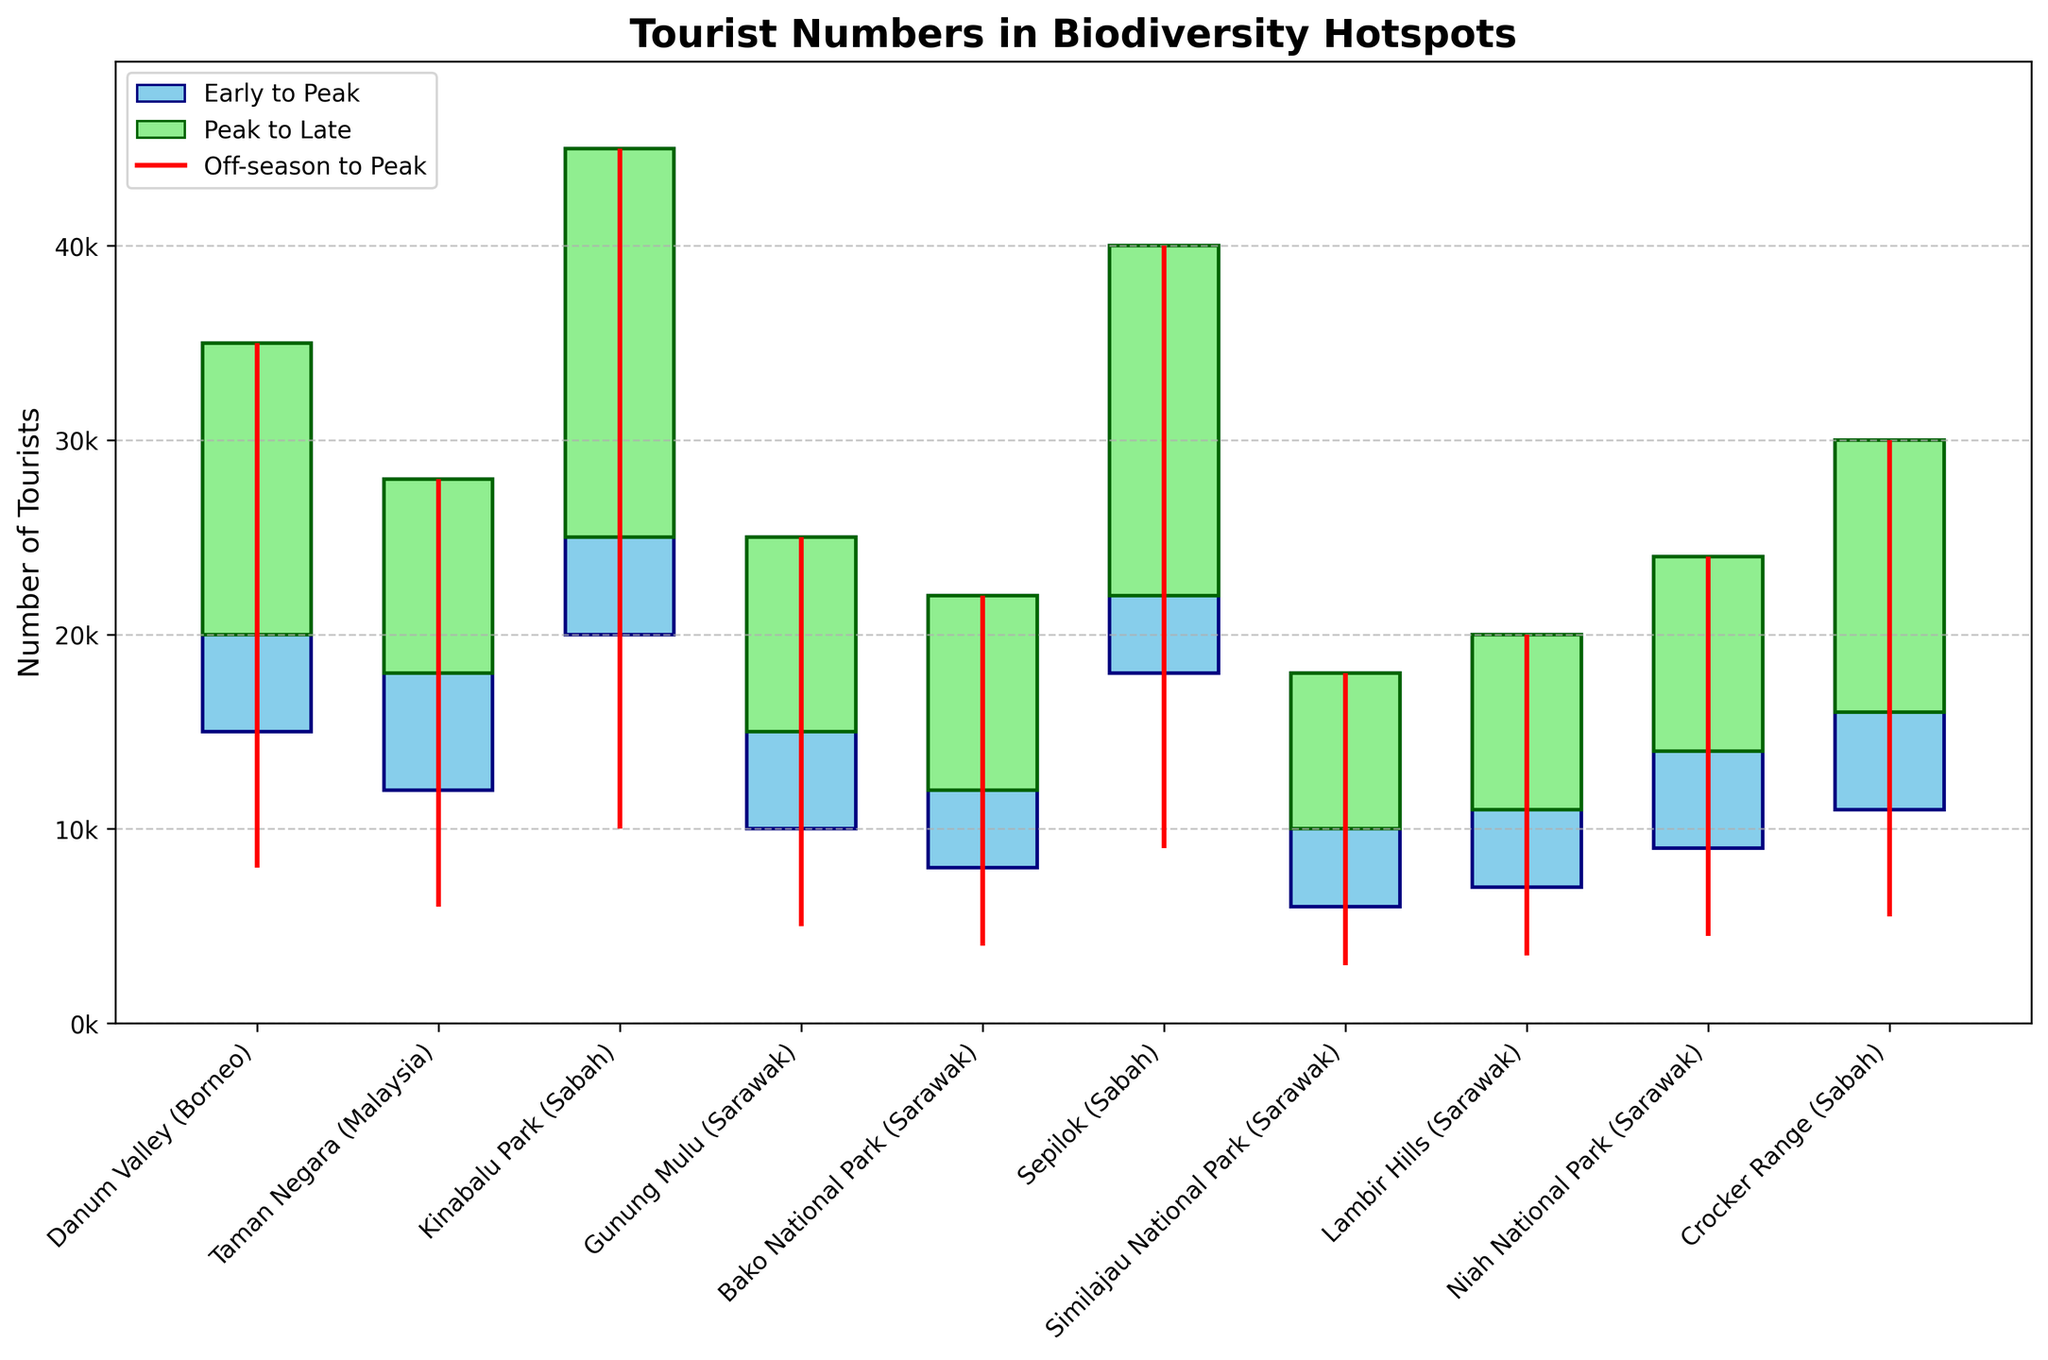What is the title of the chart? The chart title is usually at the top of the figure. In this chart, it is clear from the larger, bold font text at the top of the chart.
Answer: Tourist Numbers in Biodiversity Hotspots Which biodiversity hotspot shows the highest number of tourists in the peak season? Refer to the 'Peak' value bars. The highest peak bar corresponds to Kinabalu Park (Sabah) reaching up to 45,000 tourists.
Answer: Kinabalu Park (Sabah) What is the range of tourist numbers for Bako National Park (Sarawak) across different seasons? The range is the difference between the highest (Peak Season) and the lowest (Off-season) tourist numbers. For Bako National Park, the values are Peak: 22,000 and Off: 4,000. Therefore, the range is 22,000 - 4,000 = 18,000.
Answer: 18,000 Which season has the lowest tourist inflow for Gunung Mulu (Sarawak), and what is the number? The lowest tourist inflow is represented by the smallest value in the 'Off' column. For Gunung Mulu, it is 5,000 tourists in the off-season.
Answer: Off-season, 5,000 Between Danum Valley (Borneo) and Taman Negara (Malaysia), which one has a higher tourist number during the early season? Compare the 'Early' season numbers of both locations. Danum Valley has 15,000 while Taman Negara has 12,000. Thus, Danum Valley has a higher number.
Answer: Danum Valley (Borneo) How much does the number of tourists drop from peak season to off-season in Sepilok (Sabah)? Calculate the difference between the peak season and off-season numbers for Sepilok. The peak is 40,000 and off-season is 9,000. The drop is 40,000 - 9,000 = 31,000.
Answer: 31,000 What is the average peak season tourist number for all the hotspots? Find the peak season numbers for all locations, sum them up, and divide by the number of locations. Sum = 35,000+28,000+45,000+25,000+22,000+40,000+18,000+20,000+24,000+30,000 = 287,000. There are 10 hotspots, so the average is 287,000 / 10 = 28,700.
Answer: 28,700 How do the late season tourist numbers compare between Kinabalu Park (Sabah) and Lambir Hills (Sarawak)? Compare the 'Late' season bars for both locations. Kinabalu Park has 25,000 and Lambir Hills has 11,000. Kinabalu Park has a higher number.
Answer: Kinabalu Park (Sabah) Which hotspot has the least fluctuation in tourist numbers from early to peak season? The smallest difference between early and peak tourist numbers indicates the least fluctuation. Calculate the differences: 
Danum Valley: 35,000-15,000=20,000 
Taman Negara: 28,000-12,000=16,000 
Kinabalu Park: 45,000-20,000=25,000 
Gunung Mulu: 25,000-10,000=15,000 
Bako: 22,000-8,000=14,000 
Sepilok: 40,000-18,000=22,000 
Similajau: 18,000-6,000=12,000 
Lambir: 20,000-7,000=13,000 
Niah: 24,000-9,000=15,000 
Crocker: 30,000-11,000=19,000 
Similajau National Park (Sarawak) has the least fluctuation of 12,000.
Answer: Similajau National Park (Sarawak) 